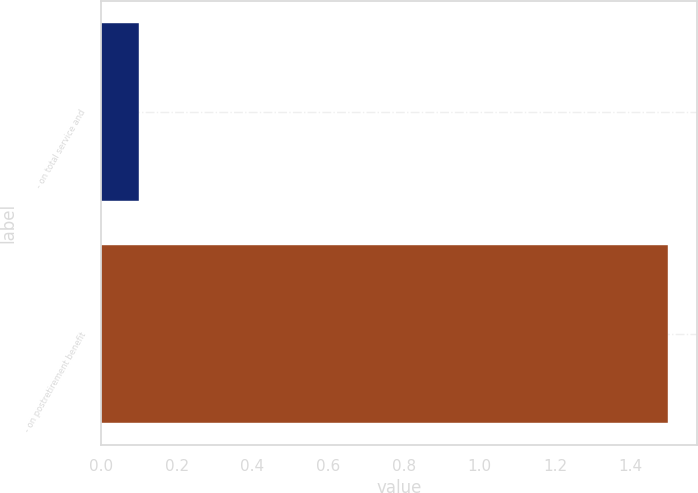<chart> <loc_0><loc_0><loc_500><loc_500><bar_chart><fcel>- on total service and<fcel>- on postretirement benefit<nl><fcel>0.1<fcel>1.5<nl></chart> 